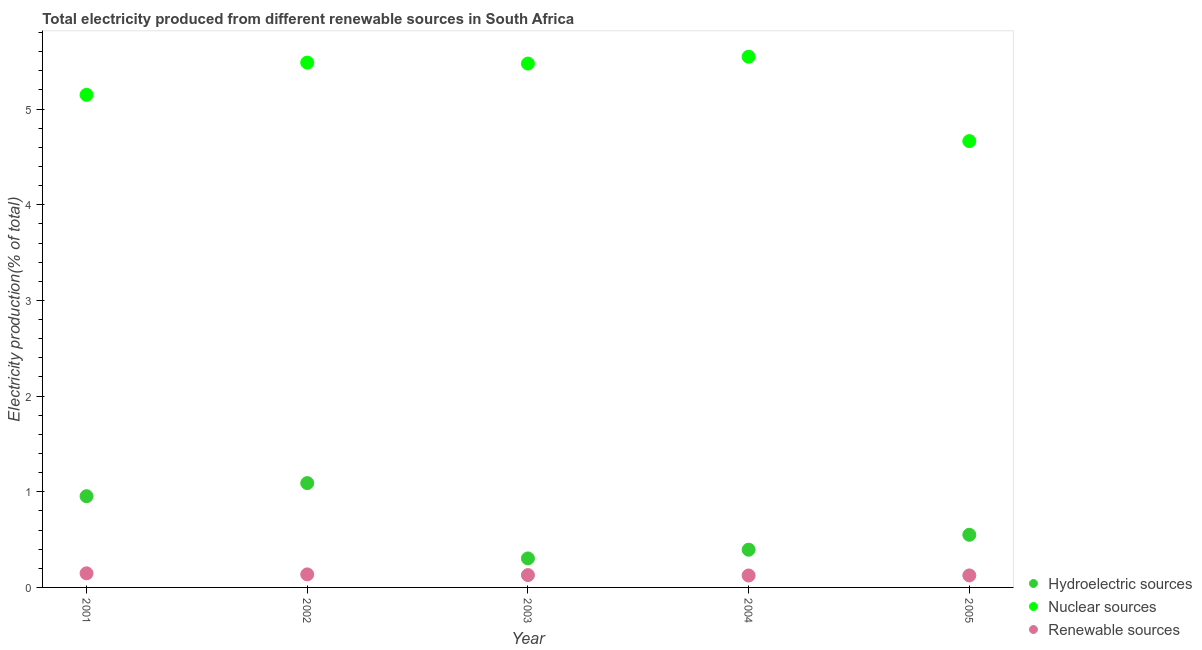How many different coloured dotlines are there?
Your response must be concise. 3. What is the percentage of electricity produced by renewable sources in 2002?
Your answer should be very brief. 0.14. Across all years, what is the maximum percentage of electricity produced by hydroelectric sources?
Offer a terse response. 1.09. Across all years, what is the minimum percentage of electricity produced by hydroelectric sources?
Offer a very short reply. 0.3. What is the total percentage of electricity produced by nuclear sources in the graph?
Offer a very short reply. 26.32. What is the difference between the percentage of electricity produced by renewable sources in 2002 and that in 2003?
Offer a terse response. 0.01. What is the difference between the percentage of electricity produced by nuclear sources in 2002 and the percentage of electricity produced by hydroelectric sources in 2004?
Make the answer very short. 5.09. What is the average percentage of electricity produced by hydroelectric sources per year?
Make the answer very short. 0.66. In the year 2005, what is the difference between the percentage of electricity produced by hydroelectric sources and percentage of electricity produced by nuclear sources?
Make the answer very short. -4.12. In how many years, is the percentage of electricity produced by nuclear sources greater than 1 %?
Provide a succinct answer. 5. What is the ratio of the percentage of electricity produced by renewable sources in 2002 to that in 2003?
Offer a very short reply. 1.06. Is the difference between the percentage of electricity produced by nuclear sources in 2001 and 2005 greater than the difference between the percentage of electricity produced by hydroelectric sources in 2001 and 2005?
Offer a very short reply. Yes. What is the difference between the highest and the second highest percentage of electricity produced by hydroelectric sources?
Provide a short and direct response. 0.14. What is the difference between the highest and the lowest percentage of electricity produced by hydroelectric sources?
Offer a very short reply. 0.79. Is the sum of the percentage of electricity produced by renewable sources in 2001 and 2003 greater than the maximum percentage of electricity produced by nuclear sources across all years?
Provide a succinct answer. No. How many years are there in the graph?
Your response must be concise. 5. Are the values on the major ticks of Y-axis written in scientific E-notation?
Your answer should be very brief. No. Does the graph contain grids?
Keep it short and to the point. No. How many legend labels are there?
Your answer should be very brief. 3. How are the legend labels stacked?
Ensure brevity in your answer.  Vertical. What is the title of the graph?
Your answer should be compact. Total electricity produced from different renewable sources in South Africa. Does "Natural Gas" appear as one of the legend labels in the graph?
Your response must be concise. No. What is the label or title of the X-axis?
Give a very brief answer. Year. What is the label or title of the Y-axis?
Your answer should be compact. Electricity production(% of total). What is the Electricity production(% of total) in Hydroelectric sources in 2001?
Provide a short and direct response. 0.95. What is the Electricity production(% of total) of Nuclear sources in 2001?
Keep it short and to the point. 5.15. What is the Electricity production(% of total) of Renewable sources in 2001?
Make the answer very short. 0.15. What is the Electricity production(% of total) in Hydroelectric sources in 2002?
Provide a succinct answer. 1.09. What is the Electricity production(% of total) in Nuclear sources in 2002?
Offer a terse response. 5.49. What is the Electricity production(% of total) of Renewable sources in 2002?
Your answer should be very brief. 0.14. What is the Electricity production(% of total) of Hydroelectric sources in 2003?
Your answer should be compact. 0.3. What is the Electricity production(% of total) of Nuclear sources in 2003?
Your answer should be compact. 5.48. What is the Electricity production(% of total) in Renewable sources in 2003?
Ensure brevity in your answer.  0.13. What is the Electricity production(% of total) of Hydroelectric sources in 2004?
Your response must be concise. 0.39. What is the Electricity production(% of total) of Nuclear sources in 2004?
Your response must be concise. 5.55. What is the Electricity production(% of total) of Renewable sources in 2004?
Ensure brevity in your answer.  0.12. What is the Electricity production(% of total) in Hydroelectric sources in 2005?
Your answer should be very brief. 0.55. What is the Electricity production(% of total) in Nuclear sources in 2005?
Offer a terse response. 4.67. What is the Electricity production(% of total) of Renewable sources in 2005?
Provide a succinct answer. 0.13. Across all years, what is the maximum Electricity production(% of total) of Hydroelectric sources?
Your answer should be very brief. 1.09. Across all years, what is the maximum Electricity production(% of total) of Nuclear sources?
Offer a very short reply. 5.55. Across all years, what is the maximum Electricity production(% of total) in Renewable sources?
Give a very brief answer. 0.15. Across all years, what is the minimum Electricity production(% of total) of Hydroelectric sources?
Ensure brevity in your answer.  0.3. Across all years, what is the minimum Electricity production(% of total) in Nuclear sources?
Your response must be concise. 4.67. Across all years, what is the minimum Electricity production(% of total) in Renewable sources?
Keep it short and to the point. 0.12. What is the total Electricity production(% of total) in Hydroelectric sources in the graph?
Make the answer very short. 3.29. What is the total Electricity production(% of total) of Nuclear sources in the graph?
Offer a very short reply. 26.32. What is the total Electricity production(% of total) in Renewable sources in the graph?
Provide a short and direct response. 0.66. What is the difference between the Electricity production(% of total) in Hydroelectric sources in 2001 and that in 2002?
Keep it short and to the point. -0.14. What is the difference between the Electricity production(% of total) in Nuclear sources in 2001 and that in 2002?
Provide a succinct answer. -0.34. What is the difference between the Electricity production(% of total) in Renewable sources in 2001 and that in 2002?
Offer a very short reply. 0.01. What is the difference between the Electricity production(% of total) in Hydroelectric sources in 2001 and that in 2003?
Make the answer very short. 0.65. What is the difference between the Electricity production(% of total) in Nuclear sources in 2001 and that in 2003?
Make the answer very short. -0.33. What is the difference between the Electricity production(% of total) of Renewable sources in 2001 and that in 2003?
Ensure brevity in your answer.  0.02. What is the difference between the Electricity production(% of total) in Hydroelectric sources in 2001 and that in 2004?
Ensure brevity in your answer.  0.56. What is the difference between the Electricity production(% of total) of Nuclear sources in 2001 and that in 2004?
Your response must be concise. -0.4. What is the difference between the Electricity production(% of total) in Renewable sources in 2001 and that in 2004?
Your response must be concise. 0.02. What is the difference between the Electricity production(% of total) in Hydroelectric sources in 2001 and that in 2005?
Your answer should be very brief. 0.4. What is the difference between the Electricity production(% of total) in Nuclear sources in 2001 and that in 2005?
Keep it short and to the point. 0.48. What is the difference between the Electricity production(% of total) in Renewable sources in 2001 and that in 2005?
Keep it short and to the point. 0.02. What is the difference between the Electricity production(% of total) in Hydroelectric sources in 2002 and that in 2003?
Ensure brevity in your answer.  0.79. What is the difference between the Electricity production(% of total) of Nuclear sources in 2002 and that in 2003?
Give a very brief answer. 0.01. What is the difference between the Electricity production(% of total) in Renewable sources in 2002 and that in 2003?
Your answer should be very brief. 0.01. What is the difference between the Electricity production(% of total) of Hydroelectric sources in 2002 and that in 2004?
Your response must be concise. 0.7. What is the difference between the Electricity production(% of total) in Nuclear sources in 2002 and that in 2004?
Provide a short and direct response. -0.06. What is the difference between the Electricity production(% of total) of Renewable sources in 2002 and that in 2004?
Offer a very short reply. 0.01. What is the difference between the Electricity production(% of total) of Hydroelectric sources in 2002 and that in 2005?
Make the answer very short. 0.54. What is the difference between the Electricity production(% of total) in Nuclear sources in 2002 and that in 2005?
Your answer should be compact. 0.82. What is the difference between the Electricity production(% of total) in Renewable sources in 2002 and that in 2005?
Provide a succinct answer. 0.01. What is the difference between the Electricity production(% of total) of Hydroelectric sources in 2003 and that in 2004?
Offer a terse response. -0.09. What is the difference between the Electricity production(% of total) of Nuclear sources in 2003 and that in 2004?
Provide a succinct answer. -0.07. What is the difference between the Electricity production(% of total) in Renewable sources in 2003 and that in 2004?
Provide a short and direct response. 0. What is the difference between the Electricity production(% of total) of Hydroelectric sources in 2003 and that in 2005?
Provide a succinct answer. -0.25. What is the difference between the Electricity production(% of total) in Nuclear sources in 2003 and that in 2005?
Your response must be concise. 0.81. What is the difference between the Electricity production(% of total) in Renewable sources in 2003 and that in 2005?
Provide a short and direct response. 0. What is the difference between the Electricity production(% of total) in Hydroelectric sources in 2004 and that in 2005?
Your answer should be compact. -0.16. What is the difference between the Electricity production(% of total) in Nuclear sources in 2004 and that in 2005?
Make the answer very short. 0.88. What is the difference between the Electricity production(% of total) of Renewable sources in 2004 and that in 2005?
Ensure brevity in your answer.  -0. What is the difference between the Electricity production(% of total) in Hydroelectric sources in 2001 and the Electricity production(% of total) in Nuclear sources in 2002?
Give a very brief answer. -4.53. What is the difference between the Electricity production(% of total) in Hydroelectric sources in 2001 and the Electricity production(% of total) in Renewable sources in 2002?
Your answer should be very brief. 0.82. What is the difference between the Electricity production(% of total) in Nuclear sources in 2001 and the Electricity production(% of total) in Renewable sources in 2002?
Offer a very short reply. 5.01. What is the difference between the Electricity production(% of total) in Hydroelectric sources in 2001 and the Electricity production(% of total) in Nuclear sources in 2003?
Ensure brevity in your answer.  -4.52. What is the difference between the Electricity production(% of total) in Hydroelectric sources in 2001 and the Electricity production(% of total) in Renewable sources in 2003?
Your answer should be very brief. 0.82. What is the difference between the Electricity production(% of total) of Nuclear sources in 2001 and the Electricity production(% of total) of Renewable sources in 2003?
Your answer should be compact. 5.02. What is the difference between the Electricity production(% of total) in Hydroelectric sources in 2001 and the Electricity production(% of total) in Nuclear sources in 2004?
Your answer should be compact. -4.59. What is the difference between the Electricity production(% of total) in Hydroelectric sources in 2001 and the Electricity production(% of total) in Renewable sources in 2004?
Make the answer very short. 0.83. What is the difference between the Electricity production(% of total) in Nuclear sources in 2001 and the Electricity production(% of total) in Renewable sources in 2004?
Your answer should be compact. 5.02. What is the difference between the Electricity production(% of total) in Hydroelectric sources in 2001 and the Electricity production(% of total) in Nuclear sources in 2005?
Make the answer very short. -3.71. What is the difference between the Electricity production(% of total) in Hydroelectric sources in 2001 and the Electricity production(% of total) in Renewable sources in 2005?
Offer a terse response. 0.83. What is the difference between the Electricity production(% of total) in Nuclear sources in 2001 and the Electricity production(% of total) in Renewable sources in 2005?
Provide a succinct answer. 5.02. What is the difference between the Electricity production(% of total) in Hydroelectric sources in 2002 and the Electricity production(% of total) in Nuclear sources in 2003?
Offer a very short reply. -4.39. What is the difference between the Electricity production(% of total) of Hydroelectric sources in 2002 and the Electricity production(% of total) of Renewable sources in 2003?
Your response must be concise. 0.96. What is the difference between the Electricity production(% of total) of Nuclear sources in 2002 and the Electricity production(% of total) of Renewable sources in 2003?
Provide a short and direct response. 5.36. What is the difference between the Electricity production(% of total) in Hydroelectric sources in 2002 and the Electricity production(% of total) in Nuclear sources in 2004?
Give a very brief answer. -4.46. What is the difference between the Electricity production(% of total) of Hydroelectric sources in 2002 and the Electricity production(% of total) of Renewable sources in 2004?
Your answer should be compact. 0.97. What is the difference between the Electricity production(% of total) in Nuclear sources in 2002 and the Electricity production(% of total) in Renewable sources in 2004?
Offer a very short reply. 5.36. What is the difference between the Electricity production(% of total) of Hydroelectric sources in 2002 and the Electricity production(% of total) of Nuclear sources in 2005?
Ensure brevity in your answer.  -3.58. What is the difference between the Electricity production(% of total) in Hydroelectric sources in 2002 and the Electricity production(% of total) in Renewable sources in 2005?
Give a very brief answer. 0.96. What is the difference between the Electricity production(% of total) of Nuclear sources in 2002 and the Electricity production(% of total) of Renewable sources in 2005?
Make the answer very short. 5.36. What is the difference between the Electricity production(% of total) of Hydroelectric sources in 2003 and the Electricity production(% of total) of Nuclear sources in 2004?
Keep it short and to the point. -5.24. What is the difference between the Electricity production(% of total) of Hydroelectric sources in 2003 and the Electricity production(% of total) of Renewable sources in 2004?
Provide a succinct answer. 0.18. What is the difference between the Electricity production(% of total) in Nuclear sources in 2003 and the Electricity production(% of total) in Renewable sources in 2004?
Make the answer very short. 5.35. What is the difference between the Electricity production(% of total) of Hydroelectric sources in 2003 and the Electricity production(% of total) of Nuclear sources in 2005?
Provide a short and direct response. -4.36. What is the difference between the Electricity production(% of total) in Hydroelectric sources in 2003 and the Electricity production(% of total) in Renewable sources in 2005?
Offer a very short reply. 0.18. What is the difference between the Electricity production(% of total) in Nuclear sources in 2003 and the Electricity production(% of total) in Renewable sources in 2005?
Ensure brevity in your answer.  5.35. What is the difference between the Electricity production(% of total) of Hydroelectric sources in 2004 and the Electricity production(% of total) of Nuclear sources in 2005?
Ensure brevity in your answer.  -4.27. What is the difference between the Electricity production(% of total) of Hydroelectric sources in 2004 and the Electricity production(% of total) of Renewable sources in 2005?
Give a very brief answer. 0.27. What is the difference between the Electricity production(% of total) in Nuclear sources in 2004 and the Electricity production(% of total) in Renewable sources in 2005?
Keep it short and to the point. 5.42. What is the average Electricity production(% of total) of Hydroelectric sources per year?
Give a very brief answer. 0.66. What is the average Electricity production(% of total) in Nuclear sources per year?
Give a very brief answer. 5.26. What is the average Electricity production(% of total) in Renewable sources per year?
Your answer should be compact. 0.13. In the year 2001, what is the difference between the Electricity production(% of total) of Hydroelectric sources and Electricity production(% of total) of Nuclear sources?
Provide a succinct answer. -4.2. In the year 2001, what is the difference between the Electricity production(% of total) of Hydroelectric sources and Electricity production(% of total) of Renewable sources?
Your response must be concise. 0.81. In the year 2001, what is the difference between the Electricity production(% of total) of Nuclear sources and Electricity production(% of total) of Renewable sources?
Offer a terse response. 5. In the year 2002, what is the difference between the Electricity production(% of total) in Hydroelectric sources and Electricity production(% of total) in Nuclear sources?
Provide a short and direct response. -4.4. In the year 2002, what is the difference between the Electricity production(% of total) in Hydroelectric sources and Electricity production(% of total) in Renewable sources?
Offer a terse response. 0.95. In the year 2002, what is the difference between the Electricity production(% of total) in Nuclear sources and Electricity production(% of total) in Renewable sources?
Provide a short and direct response. 5.35. In the year 2003, what is the difference between the Electricity production(% of total) in Hydroelectric sources and Electricity production(% of total) in Nuclear sources?
Your response must be concise. -5.17. In the year 2003, what is the difference between the Electricity production(% of total) in Hydroelectric sources and Electricity production(% of total) in Renewable sources?
Provide a short and direct response. 0.17. In the year 2003, what is the difference between the Electricity production(% of total) of Nuclear sources and Electricity production(% of total) of Renewable sources?
Provide a short and direct response. 5.35. In the year 2004, what is the difference between the Electricity production(% of total) in Hydroelectric sources and Electricity production(% of total) in Nuclear sources?
Offer a very short reply. -5.15. In the year 2004, what is the difference between the Electricity production(% of total) of Hydroelectric sources and Electricity production(% of total) of Renewable sources?
Provide a short and direct response. 0.27. In the year 2004, what is the difference between the Electricity production(% of total) in Nuclear sources and Electricity production(% of total) in Renewable sources?
Your response must be concise. 5.42. In the year 2005, what is the difference between the Electricity production(% of total) in Hydroelectric sources and Electricity production(% of total) in Nuclear sources?
Offer a terse response. -4.12. In the year 2005, what is the difference between the Electricity production(% of total) of Hydroelectric sources and Electricity production(% of total) of Renewable sources?
Provide a short and direct response. 0.42. In the year 2005, what is the difference between the Electricity production(% of total) in Nuclear sources and Electricity production(% of total) in Renewable sources?
Keep it short and to the point. 4.54. What is the ratio of the Electricity production(% of total) in Hydroelectric sources in 2001 to that in 2002?
Provide a short and direct response. 0.87. What is the ratio of the Electricity production(% of total) in Nuclear sources in 2001 to that in 2002?
Offer a very short reply. 0.94. What is the ratio of the Electricity production(% of total) in Renewable sources in 2001 to that in 2002?
Keep it short and to the point. 1.08. What is the ratio of the Electricity production(% of total) of Hydroelectric sources in 2001 to that in 2003?
Your answer should be compact. 3.15. What is the ratio of the Electricity production(% of total) of Nuclear sources in 2001 to that in 2003?
Offer a terse response. 0.94. What is the ratio of the Electricity production(% of total) of Renewable sources in 2001 to that in 2003?
Your answer should be compact. 1.14. What is the ratio of the Electricity production(% of total) of Hydroelectric sources in 2001 to that in 2004?
Keep it short and to the point. 2.42. What is the ratio of the Electricity production(% of total) of Nuclear sources in 2001 to that in 2004?
Provide a short and direct response. 0.93. What is the ratio of the Electricity production(% of total) of Renewable sources in 2001 to that in 2004?
Your answer should be compact. 1.18. What is the ratio of the Electricity production(% of total) in Hydroelectric sources in 2001 to that in 2005?
Your response must be concise. 1.73. What is the ratio of the Electricity production(% of total) of Nuclear sources in 2001 to that in 2005?
Your answer should be very brief. 1.1. What is the ratio of the Electricity production(% of total) of Renewable sources in 2001 to that in 2005?
Ensure brevity in your answer.  1.17. What is the ratio of the Electricity production(% of total) of Hydroelectric sources in 2002 to that in 2003?
Offer a very short reply. 3.6. What is the ratio of the Electricity production(% of total) of Nuclear sources in 2002 to that in 2003?
Offer a terse response. 1. What is the ratio of the Electricity production(% of total) of Renewable sources in 2002 to that in 2003?
Provide a short and direct response. 1.06. What is the ratio of the Electricity production(% of total) of Hydroelectric sources in 2002 to that in 2004?
Provide a short and direct response. 2.77. What is the ratio of the Electricity production(% of total) of Nuclear sources in 2002 to that in 2004?
Provide a short and direct response. 0.99. What is the ratio of the Electricity production(% of total) of Renewable sources in 2002 to that in 2004?
Offer a terse response. 1.09. What is the ratio of the Electricity production(% of total) of Hydroelectric sources in 2002 to that in 2005?
Your response must be concise. 1.98. What is the ratio of the Electricity production(% of total) of Nuclear sources in 2002 to that in 2005?
Make the answer very short. 1.18. What is the ratio of the Electricity production(% of total) of Renewable sources in 2002 to that in 2005?
Your response must be concise. 1.09. What is the ratio of the Electricity production(% of total) in Hydroelectric sources in 2003 to that in 2004?
Provide a short and direct response. 0.77. What is the ratio of the Electricity production(% of total) of Nuclear sources in 2003 to that in 2004?
Give a very brief answer. 0.99. What is the ratio of the Electricity production(% of total) of Renewable sources in 2003 to that in 2004?
Provide a succinct answer. 1.03. What is the ratio of the Electricity production(% of total) of Hydroelectric sources in 2003 to that in 2005?
Your response must be concise. 0.55. What is the ratio of the Electricity production(% of total) of Nuclear sources in 2003 to that in 2005?
Your answer should be very brief. 1.17. What is the ratio of the Electricity production(% of total) of Renewable sources in 2003 to that in 2005?
Your answer should be very brief. 1.03. What is the ratio of the Electricity production(% of total) of Hydroelectric sources in 2004 to that in 2005?
Provide a succinct answer. 0.72. What is the ratio of the Electricity production(% of total) of Nuclear sources in 2004 to that in 2005?
Give a very brief answer. 1.19. What is the difference between the highest and the second highest Electricity production(% of total) in Hydroelectric sources?
Offer a terse response. 0.14. What is the difference between the highest and the second highest Electricity production(% of total) in Nuclear sources?
Your answer should be very brief. 0.06. What is the difference between the highest and the second highest Electricity production(% of total) in Renewable sources?
Provide a short and direct response. 0.01. What is the difference between the highest and the lowest Electricity production(% of total) in Hydroelectric sources?
Provide a short and direct response. 0.79. What is the difference between the highest and the lowest Electricity production(% of total) of Nuclear sources?
Keep it short and to the point. 0.88. What is the difference between the highest and the lowest Electricity production(% of total) of Renewable sources?
Offer a terse response. 0.02. 